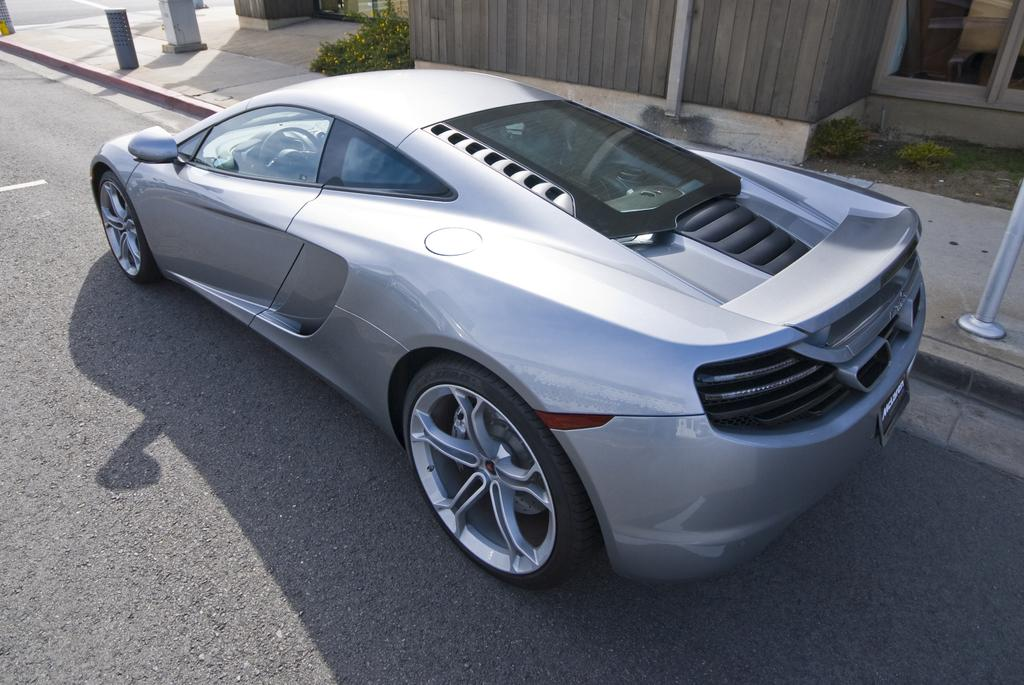What is the main subject of the picture? The main subject of the picture is a car. Can you describe the car's appearance? The car is silver in color and has two doors. What else can be seen in the picture besides the car? There is a building and plants in the picture. How many chairs are placed around the mint plant in the image? There are no chairs or mint plants present in the image. What type of oranges can be seen growing on the trees in the image? There are no orange trees or oranges visible in the image. 